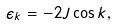<formula> <loc_0><loc_0><loc_500><loc_500>\epsilon _ { k } = - 2 J \cos k ,</formula> 